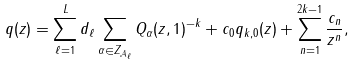<formula> <loc_0><loc_0><loc_500><loc_500>q ( z ) = \sum _ { \ell = 1 } ^ { L } d _ { \ell } \sum _ { \alpha \in Z _ { \mathcal { A } _ { \ell } } } Q _ { \alpha } ( z , 1 ) ^ { - k } + c _ { 0 } q _ { k , 0 } ( z ) + \sum _ { n = 1 } ^ { 2 k - 1 } \frac { c _ { n } } { z ^ { n } } ,</formula> 